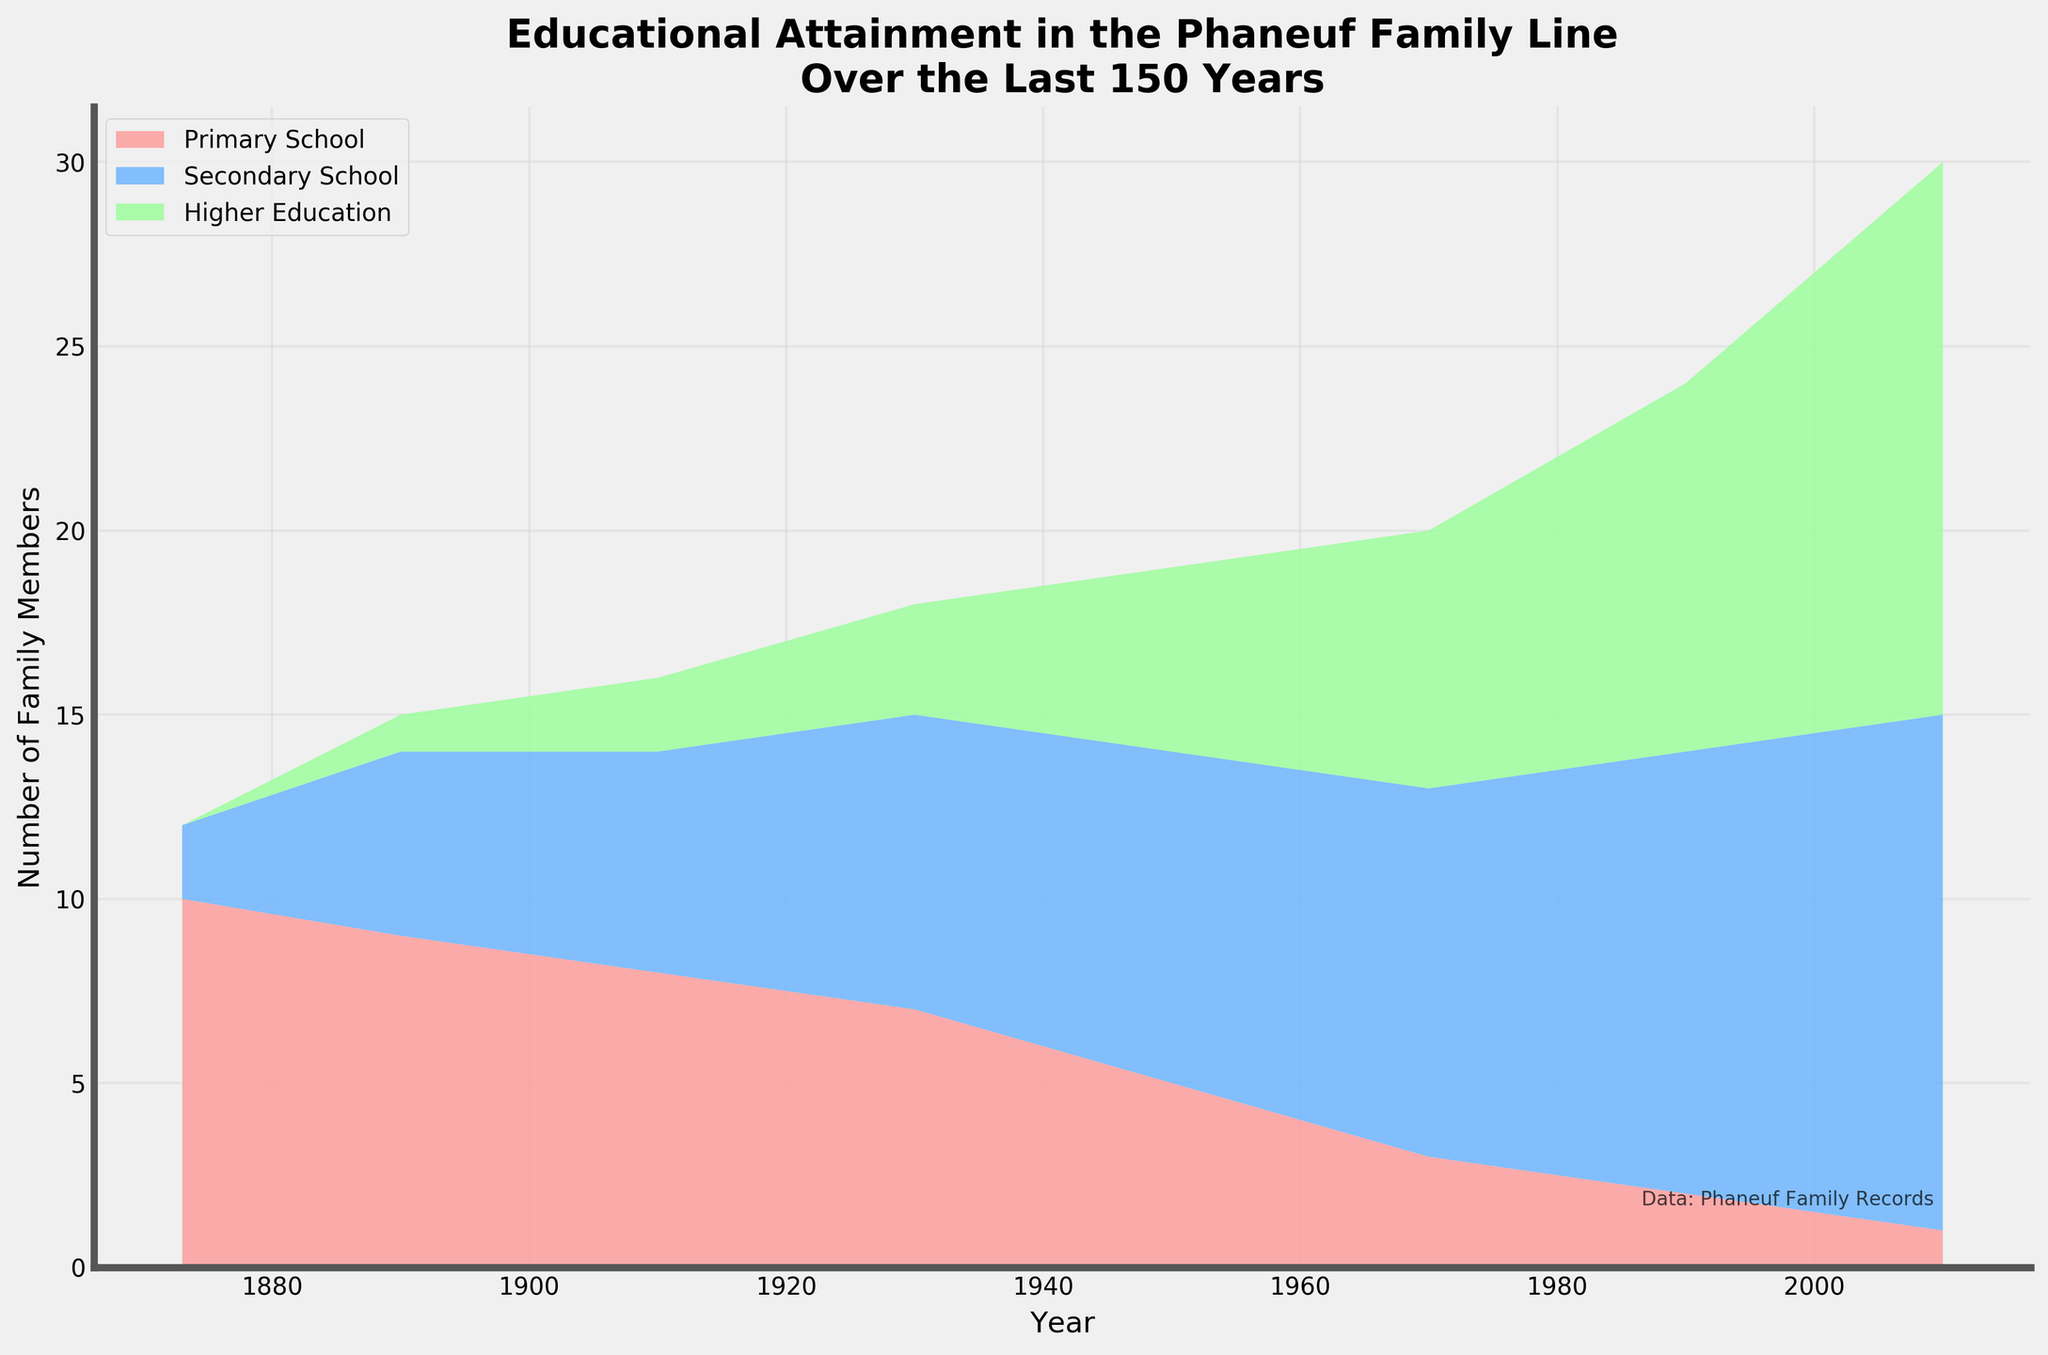How many family members had higher education in 1950? Check the count for higher education in the year 1950 from the stream graph.
Answer: 5 How did the number of family members with primary school education change from 1873 to 1990? Compare the counts for primary school education in 1873 (10) and in 1990 (2).
Answer: Decreased Across the timeline, which educational attainment level saw the most consistent growth? Observe the trends for each category; higher education consistently increases while primary and secondary levels fluctuate.
Answer: Higher education By how much did the number of family members with secondary school education increase from 1930 to 2010? The count in 1930 is 8, and in 2010 is 14. Calculate the difference (14 - 8).
Answer: 6 Which year saw the highest number of family members in secondary school education? Find the year where the secondary school stream widens the most.
Answer: 2010 In 1970, what is the total number of family members with secondary school and higher education combined? Sum the counts for secondary school (10) and higher education (7) in 1970.
Answer: 17 During which decade did the Phaneuf family see the largest increase in higher education attainment? Compare the increments each decade (e.g., 1930 to 1950, etc.) for higher education.
Answer: 1950-1970 What is the trend of primary school education from 1950 onwards? Observe the stream for primary school from 1950 to 2010, which shows a downward trend.
Answer: Decreasing In which year was the total number of family members’ educational attainment the highest? For each year, add up the counts of all education levels and identify the max total; 2010 shows the highest count when summed.
Answer: 2010 